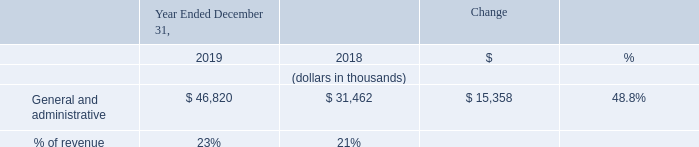General and Administrative Expense
General and administrative expense increased by $15.4 million in 2019 compared to 2018. The increase was primarily due to a $9.8 million increase in employee-related costs, which includes stock-based compensation, associated with our increased headcount from 89 employees as of December 31, 2018 to 113 employees as of December 31, 2019. There was an additional increase of $3.7 million in depreciation and amortization, $0.8 million to support compliance as a public company, a $0.6 million increase in office related expenses to support the administrative team, and an increase of $0.2 million in software subscription costs.
What was the increase in the General and administrative expense in 2019? $15.4 million. What was the increase in the cost of depreciation and amortization from 2018 to 2019? $3.7 million. What was the % of revenue for General and administrative expense in 2019 and 2018?
Answer scale should be: percent. 23, 21. What was the average General and administrative expense for 2018 and 2019?
Answer scale should be: thousand. (46,820 + 31,462) / 2
Answer: 39141. In which year was General and administrative expenses less than 50,000 thousands? Locate and analyze general and administrative in row 4
answer: 2019, 2018. What is the change in the % of revenue from 2018 to 2019?
Answer scale should be: percent. 23 - 21
Answer: 2. 